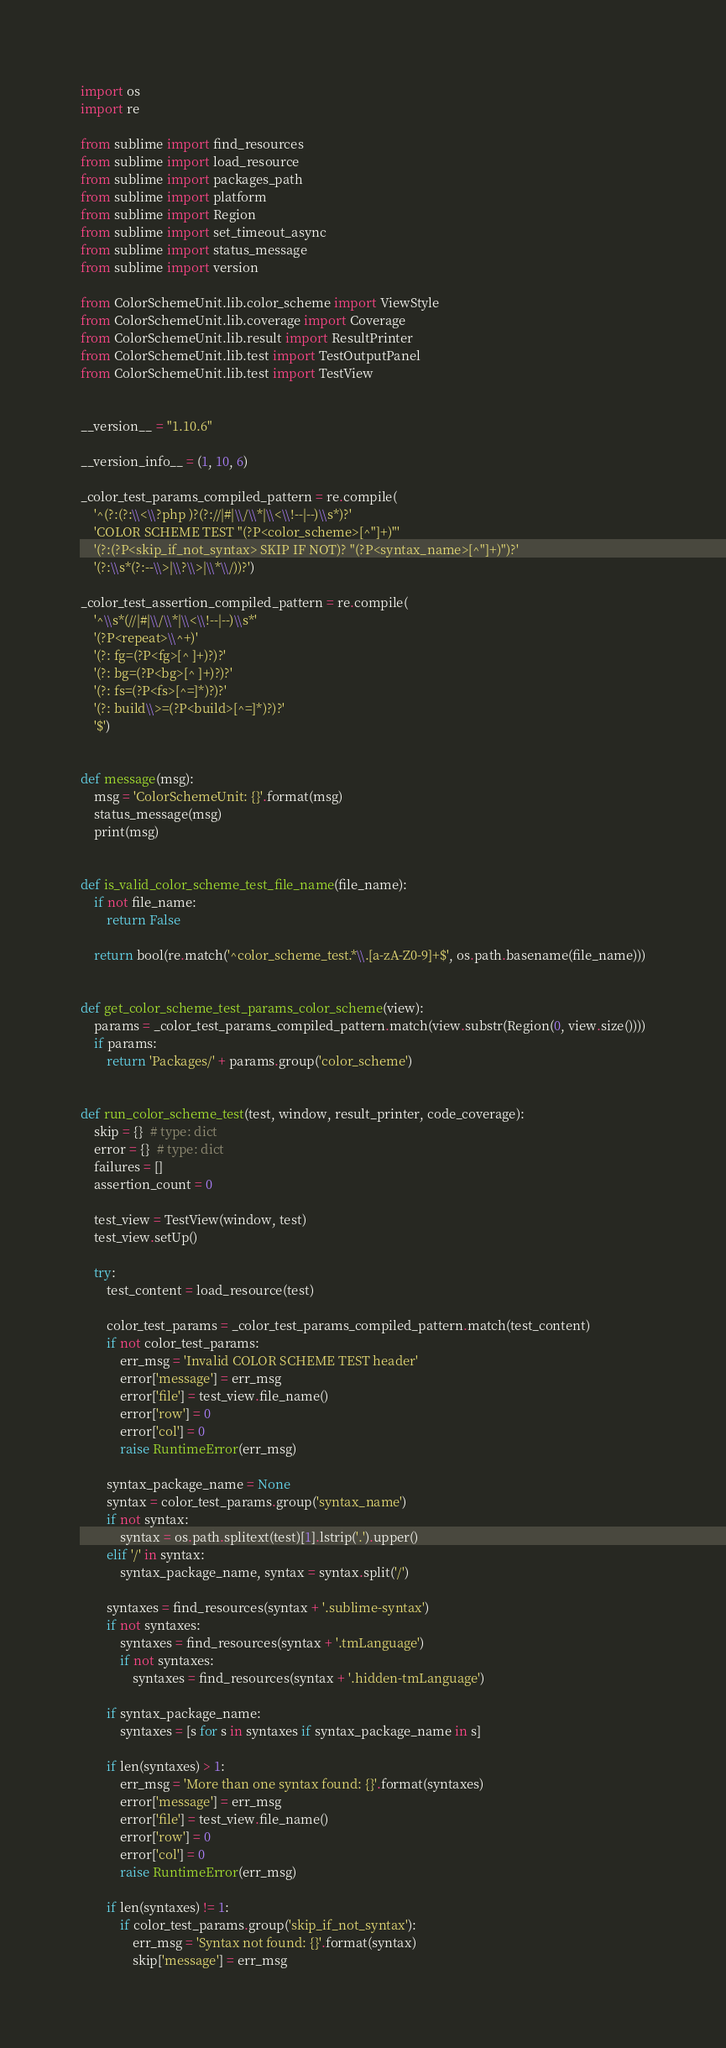<code> <loc_0><loc_0><loc_500><loc_500><_Python_>import os
import re

from sublime import find_resources
from sublime import load_resource
from sublime import packages_path
from sublime import platform
from sublime import Region
from sublime import set_timeout_async
from sublime import status_message
from sublime import version

from ColorSchemeUnit.lib.color_scheme import ViewStyle
from ColorSchemeUnit.lib.coverage import Coverage
from ColorSchemeUnit.lib.result import ResultPrinter
from ColorSchemeUnit.lib.test import TestOutputPanel
from ColorSchemeUnit.lib.test import TestView


__version__ = "1.10.6"

__version_info__ = (1, 10, 6)

_color_test_params_compiled_pattern = re.compile(
    '^(?:(?:\\<\\?php )?(?://|#|\\/\\*|\\<\\!--|--)\\s*)?'
    'COLOR SCHEME TEST "(?P<color_scheme>[^"]+)"'
    '(?:(?P<skip_if_not_syntax> SKIP IF NOT)? "(?P<syntax_name>[^"]+)")?'
    '(?:\\s*(?:--\\>|\\?\\>|\\*\\/))?')

_color_test_assertion_compiled_pattern = re.compile(
    '^\\s*(//|#|\\/\\*|\\<\\!--|--)\\s*'
    '(?P<repeat>\\^+)'
    '(?: fg=(?P<fg>[^ ]+)?)?'
    '(?: bg=(?P<bg>[^ ]+)?)?'
    '(?: fs=(?P<fs>[^=]*)?)?'
    '(?: build\\>=(?P<build>[^=]*)?)?'
    '$')


def message(msg):
    msg = 'ColorSchemeUnit: {}'.format(msg)
    status_message(msg)
    print(msg)


def is_valid_color_scheme_test_file_name(file_name):
    if not file_name:
        return False

    return bool(re.match('^color_scheme_test.*\\.[a-zA-Z0-9]+$', os.path.basename(file_name)))


def get_color_scheme_test_params_color_scheme(view):
    params = _color_test_params_compiled_pattern.match(view.substr(Region(0, view.size())))
    if params:
        return 'Packages/' + params.group('color_scheme')


def run_color_scheme_test(test, window, result_printer, code_coverage):
    skip = {}  # type: dict
    error = {}  # type: dict
    failures = []
    assertion_count = 0

    test_view = TestView(window, test)
    test_view.setUp()

    try:
        test_content = load_resource(test)

        color_test_params = _color_test_params_compiled_pattern.match(test_content)
        if not color_test_params:
            err_msg = 'Invalid COLOR SCHEME TEST header'
            error['message'] = err_msg
            error['file'] = test_view.file_name()
            error['row'] = 0
            error['col'] = 0
            raise RuntimeError(err_msg)

        syntax_package_name = None
        syntax = color_test_params.group('syntax_name')
        if not syntax:
            syntax = os.path.splitext(test)[1].lstrip('.').upper()
        elif '/' in syntax:
            syntax_package_name, syntax = syntax.split('/')

        syntaxes = find_resources(syntax + '.sublime-syntax')
        if not syntaxes:
            syntaxes = find_resources(syntax + '.tmLanguage')
            if not syntaxes:
                syntaxes = find_resources(syntax + '.hidden-tmLanguage')

        if syntax_package_name:
            syntaxes = [s for s in syntaxes if syntax_package_name in s]

        if len(syntaxes) > 1:
            err_msg = 'More than one syntax found: {}'.format(syntaxes)
            error['message'] = err_msg
            error['file'] = test_view.file_name()
            error['row'] = 0
            error['col'] = 0
            raise RuntimeError(err_msg)

        if len(syntaxes) != 1:
            if color_test_params.group('skip_if_not_syntax'):
                err_msg = 'Syntax not found: {}'.format(syntax)
                skip['message'] = err_msg</code> 